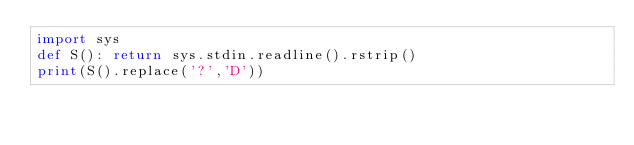Convert code to text. <code><loc_0><loc_0><loc_500><loc_500><_Python_>import sys
def S(): return sys.stdin.readline().rstrip()
print(S().replace('?','D'))
</code> 